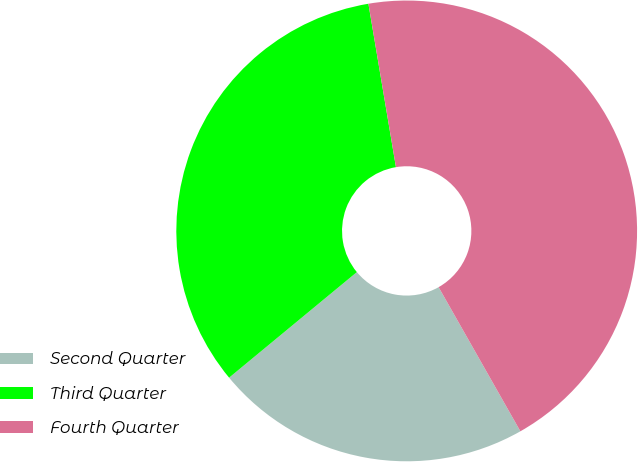Convert chart. <chart><loc_0><loc_0><loc_500><loc_500><pie_chart><fcel>Second Quarter<fcel>Third Quarter<fcel>Fourth Quarter<nl><fcel>22.22%<fcel>33.33%<fcel>44.44%<nl></chart> 